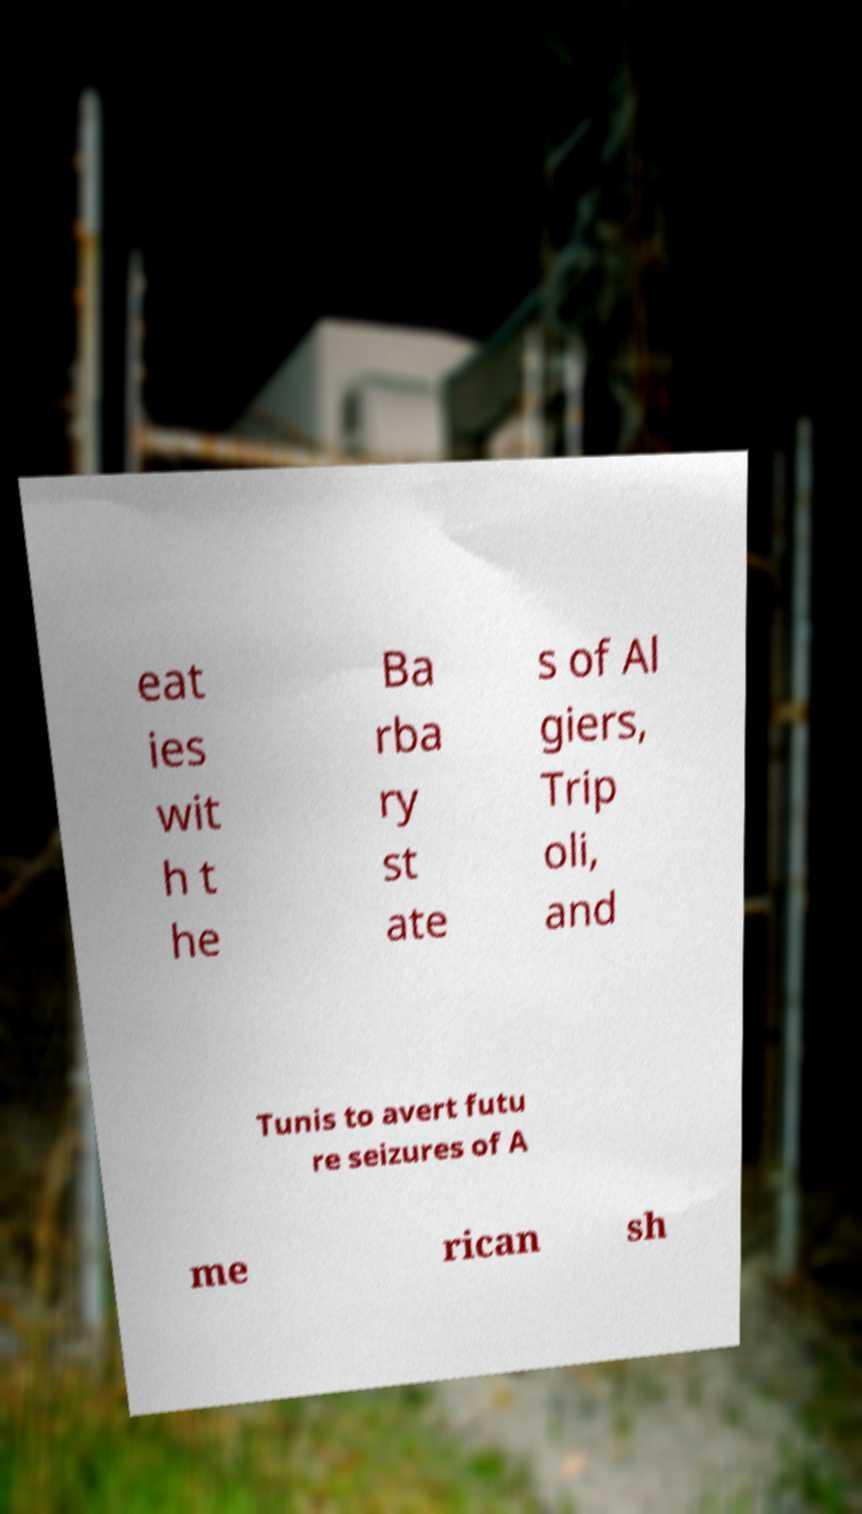Could you extract and type out the text from this image? eat ies wit h t he Ba rba ry st ate s of Al giers, Trip oli, and Tunis to avert futu re seizures of A me rican sh 